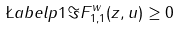<formula> <loc_0><loc_0><loc_500><loc_500>\L a b e l { p 1 } \Im F ^ { w } _ { 1 , 1 } ( z , u ) \geq 0</formula> 